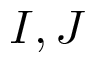<formula> <loc_0><loc_0><loc_500><loc_500>I , J</formula> 